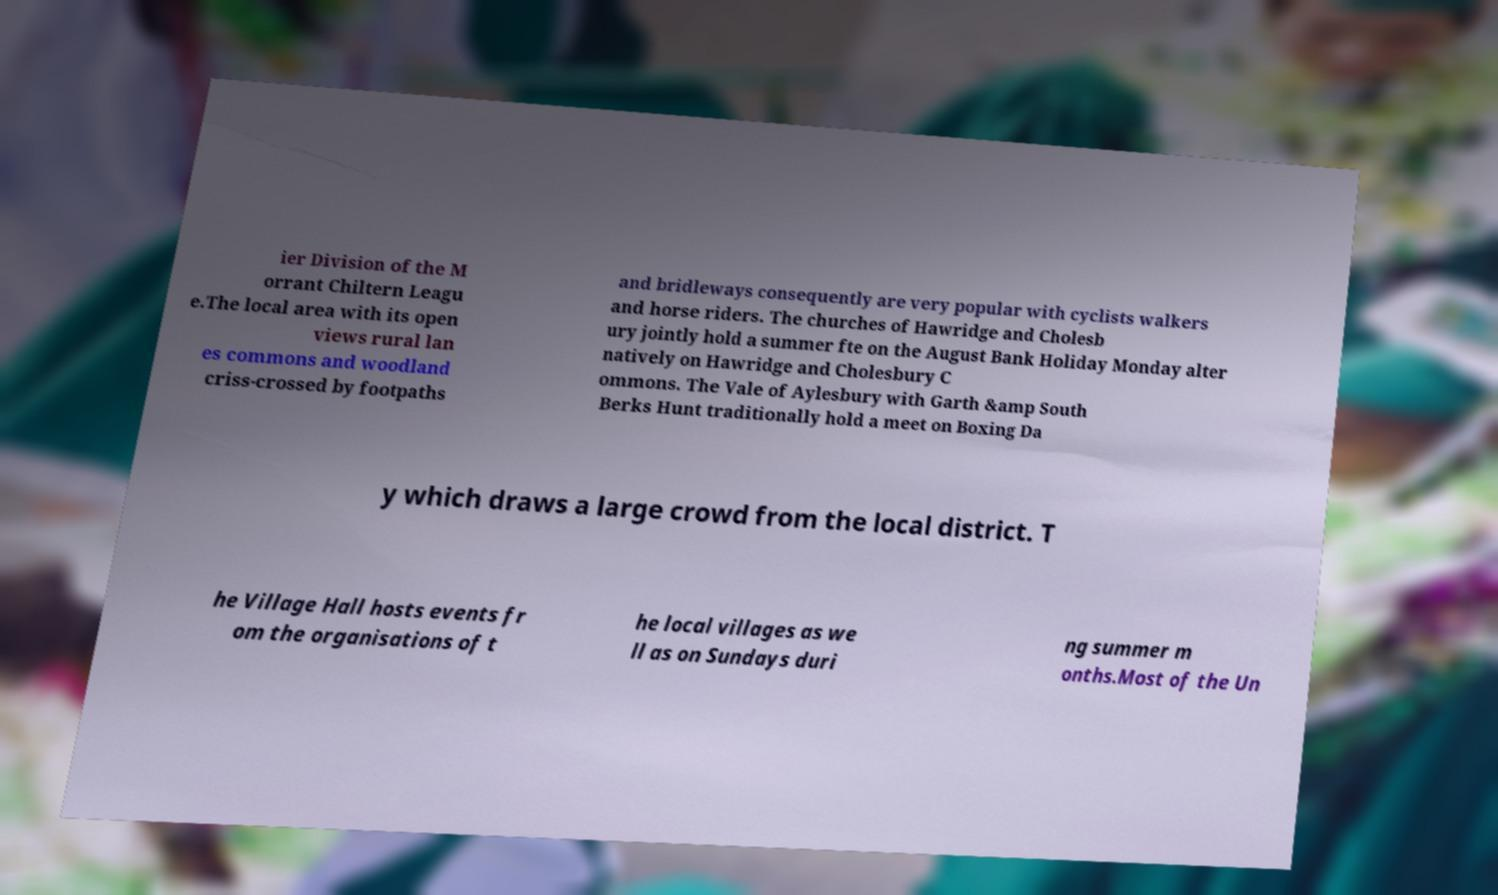Could you extract and type out the text from this image? ier Division of the M orrant Chiltern Leagu e.The local area with its open views rural lan es commons and woodland criss-crossed by footpaths and bridleways consequently are very popular with cyclists walkers and horse riders. The churches of Hawridge and Cholesb ury jointly hold a summer fte on the August Bank Holiday Monday alter natively on Hawridge and Cholesbury C ommons. The Vale of Aylesbury with Garth &amp South Berks Hunt traditionally hold a meet on Boxing Da y which draws a large crowd from the local district. T he Village Hall hosts events fr om the organisations of t he local villages as we ll as on Sundays duri ng summer m onths.Most of the Un 